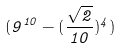Convert formula to latex. <formula><loc_0><loc_0><loc_500><loc_500>( 9 ^ { 1 0 } - ( \frac { \sqrt { 2 } } { 1 0 } ) ^ { 4 } )</formula> 